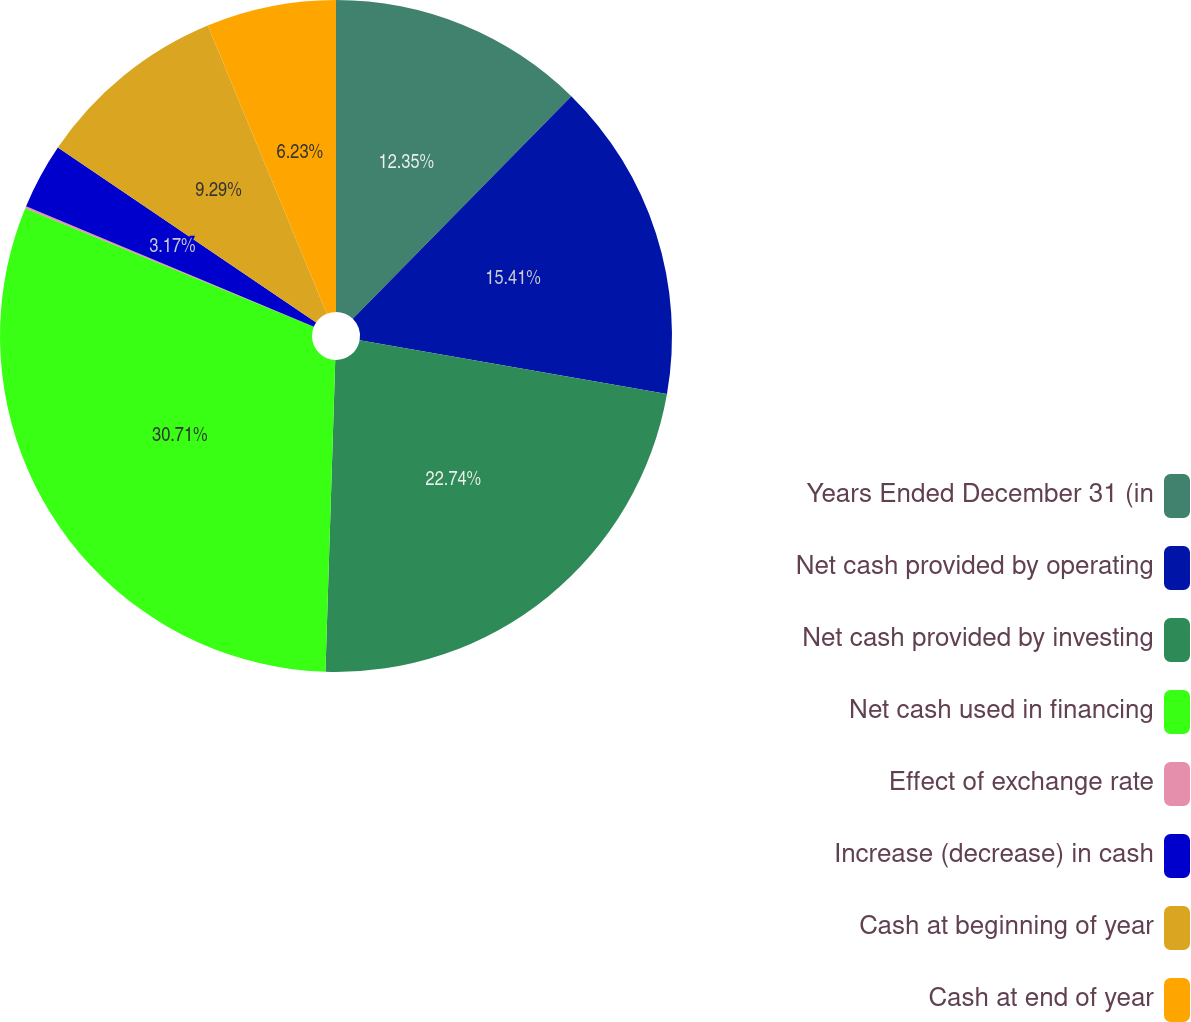Convert chart to OTSL. <chart><loc_0><loc_0><loc_500><loc_500><pie_chart><fcel>Years Ended December 31 (in<fcel>Net cash provided by operating<fcel>Net cash provided by investing<fcel>Net cash used in financing<fcel>Effect of exchange rate<fcel>Increase (decrease) in cash<fcel>Cash at beginning of year<fcel>Cash at end of year<nl><fcel>12.35%<fcel>15.41%<fcel>22.74%<fcel>30.71%<fcel>0.1%<fcel>3.17%<fcel>9.29%<fcel>6.23%<nl></chart> 